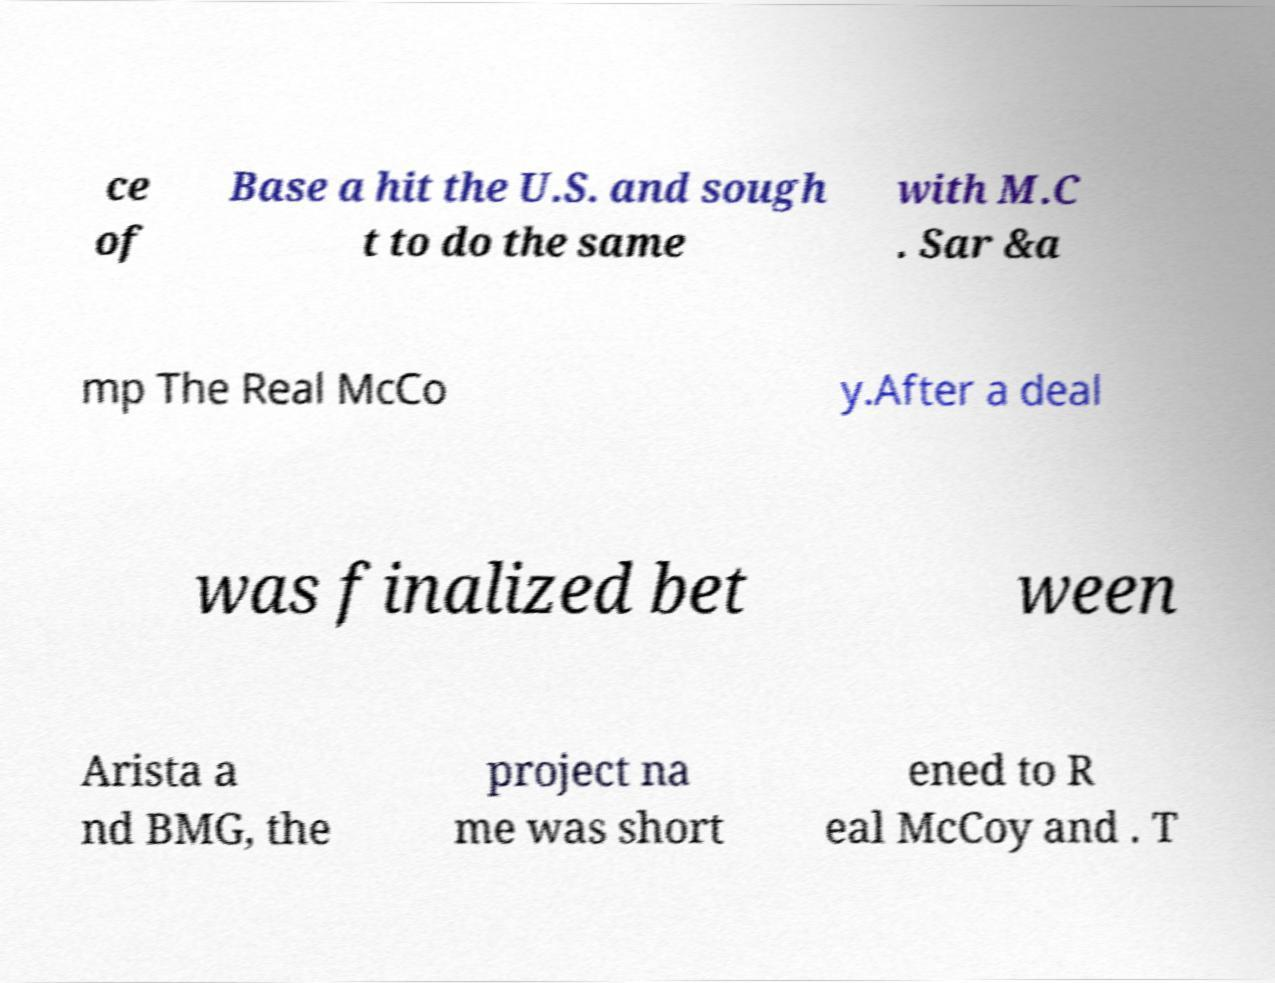Can you read and provide the text displayed in the image?This photo seems to have some interesting text. Can you extract and type it out for me? ce of Base a hit the U.S. and sough t to do the same with M.C . Sar &a mp The Real McCo y.After a deal was finalized bet ween Arista a nd BMG, the project na me was short ened to R eal McCoy and . T 